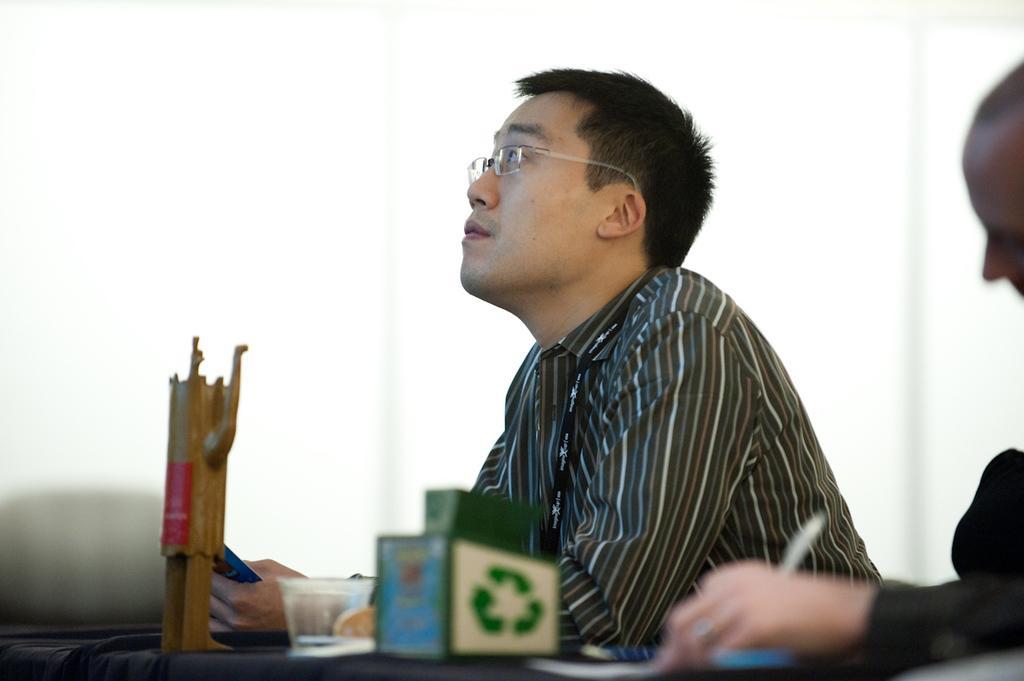Can you describe this image briefly? In this image a person wearing a shirt is sitting before a table having cup, box and wooden stand on it. Person is wearing spectacles. Right side there is a person holding a pen. 